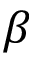Convert formula to latex. <formula><loc_0><loc_0><loc_500><loc_500>\beta</formula> 